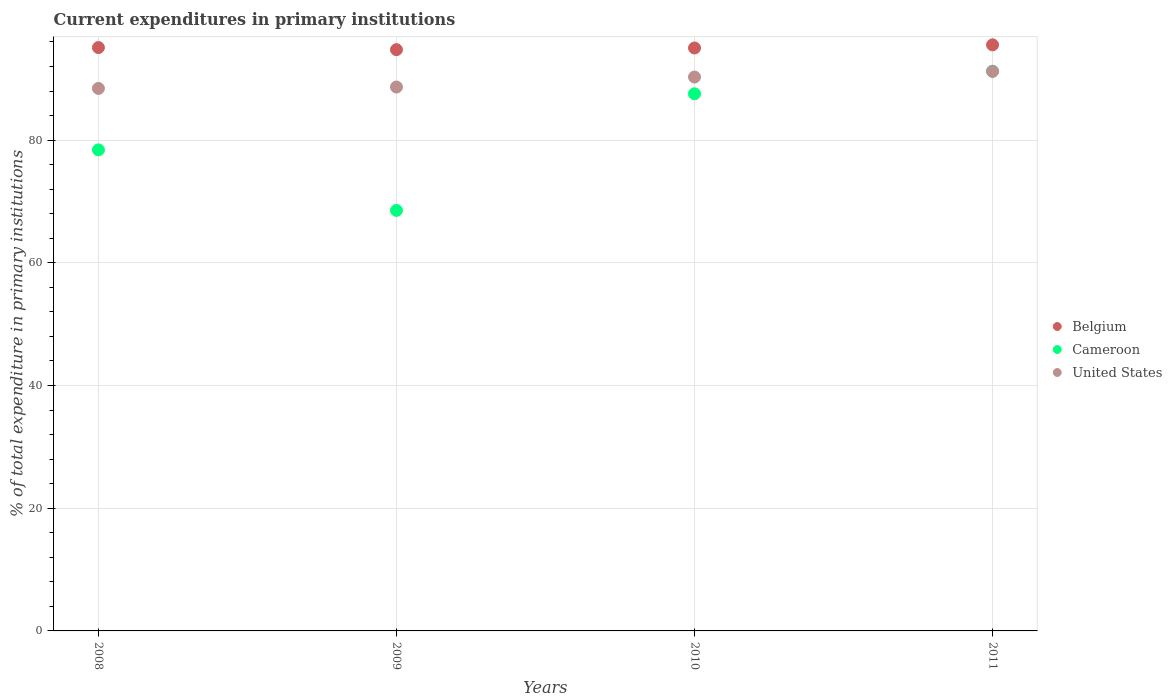Is the number of dotlines equal to the number of legend labels?
Offer a very short reply. Yes. What is the current expenditures in primary institutions in United States in 2008?
Your answer should be very brief. 88.42. Across all years, what is the maximum current expenditures in primary institutions in Cameroon?
Make the answer very short. 91.22. Across all years, what is the minimum current expenditures in primary institutions in United States?
Provide a short and direct response. 88.42. In which year was the current expenditures in primary institutions in United States maximum?
Keep it short and to the point. 2011. In which year was the current expenditures in primary institutions in Belgium minimum?
Ensure brevity in your answer.  2009. What is the total current expenditures in primary institutions in Cameroon in the graph?
Offer a very short reply. 325.71. What is the difference between the current expenditures in primary institutions in Belgium in 2009 and that in 2010?
Offer a terse response. -0.27. What is the difference between the current expenditures in primary institutions in Cameroon in 2011 and the current expenditures in primary institutions in Belgium in 2009?
Offer a terse response. -3.52. What is the average current expenditures in primary institutions in United States per year?
Offer a terse response. 89.64. In the year 2010, what is the difference between the current expenditures in primary institutions in Belgium and current expenditures in primary institutions in Cameroon?
Provide a succinct answer. 7.47. In how many years, is the current expenditures in primary institutions in Cameroon greater than 28 %?
Offer a terse response. 4. What is the ratio of the current expenditures in primary institutions in Cameroon in 2009 to that in 2011?
Your answer should be very brief. 0.75. What is the difference between the highest and the second highest current expenditures in primary institutions in United States?
Give a very brief answer. 0.93. What is the difference between the highest and the lowest current expenditures in primary institutions in Cameroon?
Offer a terse response. 22.68. Is it the case that in every year, the sum of the current expenditures in primary institutions in United States and current expenditures in primary institutions in Belgium  is greater than the current expenditures in primary institutions in Cameroon?
Offer a very short reply. Yes. Does the current expenditures in primary institutions in United States monotonically increase over the years?
Make the answer very short. Yes. Does the graph contain any zero values?
Give a very brief answer. No. Does the graph contain grids?
Your response must be concise. Yes. How many legend labels are there?
Make the answer very short. 3. How are the legend labels stacked?
Ensure brevity in your answer.  Vertical. What is the title of the graph?
Keep it short and to the point. Current expenditures in primary institutions. What is the label or title of the X-axis?
Your answer should be very brief. Years. What is the label or title of the Y-axis?
Offer a very short reply. % of total expenditure in primary institutions. What is the % of total expenditure in primary institutions of Belgium in 2008?
Your response must be concise. 95.08. What is the % of total expenditure in primary institutions of Cameroon in 2008?
Keep it short and to the point. 78.41. What is the % of total expenditure in primary institutions of United States in 2008?
Your answer should be compact. 88.42. What is the % of total expenditure in primary institutions in Belgium in 2009?
Your response must be concise. 94.74. What is the % of total expenditure in primary institutions in Cameroon in 2009?
Your response must be concise. 68.54. What is the % of total expenditure in primary institutions in United States in 2009?
Offer a very short reply. 88.65. What is the % of total expenditure in primary institutions of Belgium in 2010?
Provide a succinct answer. 95.01. What is the % of total expenditure in primary institutions in Cameroon in 2010?
Offer a terse response. 87.54. What is the % of total expenditure in primary institutions in United States in 2010?
Offer a very short reply. 90.27. What is the % of total expenditure in primary institutions of Belgium in 2011?
Your response must be concise. 95.52. What is the % of total expenditure in primary institutions of Cameroon in 2011?
Provide a short and direct response. 91.22. What is the % of total expenditure in primary institutions of United States in 2011?
Keep it short and to the point. 91.21. Across all years, what is the maximum % of total expenditure in primary institutions in Belgium?
Offer a very short reply. 95.52. Across all years, what is the maximum % of total expenditure in primary institutions in Cameroon?
Your answer should be compact. 91.22. Across all years, what is the maximum % of total expenditure in primary institutions of United States?
Your response must be concise. 91.21. Across all years, what is the minimum % of total expenditure in primary institutions in Belgium?
Offer a terse response. 94.74. Across all years, what is the minimum % of total expenditure in primary institutions of Cameroon?
Offer a very short reply. 68.54. Across all years, what is the minimum % of total expenditure in primary institutions of United States?
Your answer should be very brief. 88.42. What is the total % of total expenditure in primary institutions in Belgium in the graph?
Offer a terse response. 380.36. What is the total % of total expenditure in primary institutions of Cameroon in the graph?
Keep it short and to the point. 325.71. What is the total % of total expenditure in primary institutions of United States in the graph?
Provide a short and direct response. 358.55. What is the difference between the % of total expenditure in primary institutions in Belgium in 2008 and that in 2009?
Give a very brief answer. 0.34. What is the difference between the % of total expenditure in primary institutions of Cameroon in 2008 and that in 2009?
Keep it short and to the point. 9.87. What is the difference between the % of total expenditure in primary institutions in United States in 2008 and that in 2009?
Make the answer very short. -0.23. What is the difference between the % of total expenditure in primary institutions in Belgium in 2008 and that in 2010?
Keep it short and to the point. 0.07. What is the difference between the % of total expenditure in primary institutions in Cameroon in 2008 and that in 2010?
Your response must be concise. -9.14. What is the difference between the % of total expenditure in primary institutions in United States in 2008 and that in 2010?
Your response must be concise. -1.85. What is the difference between the % of total expenditure in primary institutions of Belgium in 2008 and that in 2011?
Your answer should be compact. -0.44. What is the difference between the % of total expenditure in primary institutions in Cameroon in 2008 and that in 2011?
Your response must be concise. -12.81. What is the difference between the % of total expenditure in primary institutions in United States in 2008 and that in 2011?
Give a very brief answer. -2.78. What is the difference between the % of total expenditure in primary institutions of Belgium in 2009 and that in 2010?
Offer a terse response. -0.27. What is the difference between the % of total expenditure in primary institutions in Cameroon in 2009 and that in 2010?
Your response must be concise. -19. What is the difference between the % of total expenditure in primary institutions in United States in 2009 and that in 2010?
Make the answer very short. -1.63. What is the difference between the % of total expenditure in primary institutions of Belgium in 2009 and that in 2011?
Keep it short and to the point. -0.78. What is the difference between the % of total expenditure in primary institutions in Cameroon in 2009 and that in 2011?
Your response must be concise. -22.68. What is the difference between the % of total expenditure in primary institutions of United States in 2009 and that in 2011?
Provide a succinct answer. -2.56. What is the difference between the % of total expenditure in primary institutions in Belgium in 2010 and that in 2011?
Ensure brevity in your answer.  -0.51. What is the difference between the % of total expenditure in primary institutions in Cameroon in 2010 and that in 2011?
Your answer should be compact. -3.68. What is the difference between the % of total expenditure in primary institutions of United States in 2010 and that in 2011?
Your answer should be compact. -0.93. What is the difference between the % of total expenditure in primary institutions of Belgium in 2008 and the % of total expenditure in primary institutions of Cameroon in 2009?
Your answer should be very brief. 26.54. What is the difference between the % of total expenditure in primary institutions of Belgium in 2008 and the % of total expenditure in primary institutions of United States in 2009?
Give a very brief answer. 6.43. What is the difference between the % of total expenditure in primary institutions of Cameroon in 2008 and the % of total expenditure in primary institutions of United States in 2009?
Offer a very short reply. -10.24. What is the difference between the % of total expenditure in primary institutions in Belgium in 2008 and the % of total expenditure in primary institutions in Cameroon in 2010?
Offer a very short reply. 7.54. What is the difference between the % of total expenditure in primary institutions of Belgium in 2008 and the % of total expenditure in primary institutions of United States in 2010?
Offer a terse response. 4.81. What is the difference between the % of total expenditure in primary institutions in Cameroon in 2008 and the % of total expenditure in primary institutions in United States in 2010?
Offer a terse response. -11.87. What is the difference between the % of total expenditure in primary institutions of Belgium in 2008 and the % of total expenditure in primary institutions of Cameroon in 2011?
Provide a short and direct response. 3.86. What is the difference between the % of total expenditure in primary institutions of Belgium in 2008 and the % of total expenditure in primary institutions of United States in 2011?
Keep it short and to the point. 3.88. What is the difference between the % of total expenditure in primary institutions in Cameroon in 2008 and the % of total expenditure in primary institutions in United States in 2011?
Ensure brevity in your answer.  -12.8. What is the difference between the % of total expenditure in primary institutions of Belgium in 2009 and the % of total expenditure in primary institutions of Cameroon in 2010?
Keep it short and to the point. 7.2. What is the difference between the % of total expenditure in primary institutions in Belgium in 2009 and the % of total expenditure in primary institutions in United States in 2010?
Keep it short and to the point. 4.46. What is the difference between the % of total expenditure in primary institutions in Cameroon in 2009 and the % of total expenditure in primary institutions in United States in 2010?
Provide a short and direct response. -21.73. What is the difference between the % of total expenditure in primary institutions of Belgium in 2009 and the % of total expenditure in primary institutions of Cameroon in 2011?
Offer a very short reply. 3.52. What is the difference between the % of total expenditure in primary institutions of Belgium in 2009 and the % of total expenditure in primary institutions of United States in 2011?
Offer a very short reply. 3.53. What is the difference between the % of total expenditure in primary institutions of Cameroon in 2009 and the % of total expenditure in primary institutions of United States in 2011?
Provide a succinct answer. -22.66. What is the difference between the % of total expenditure in primary institutions in Belgium in 2010 and the % of total expenditure in primary institutions in Cameroon in 2011?
Offer a very short reply. 3.79. What is the difference between the % of total expenditure in primary institutions in Belgium in 2010 and the % of total expenditure in primary institutions in United States in 2011?
Ensure brevity in your answer.  3.81. What is the difference between the % of total expenditure in primary institutions of Cameroon in 2010 and the % of total expenditure in primary institutions of United States in 2011?
Ensure brevity in your answer.  -3.66. What is the average % of total expenditure in primary institutions of Belgium per year?
Provide a succinct answer. 95.09. What is the average % of total expenditure in primary institutions in Cameroon per year?
Ensure brevity in your answer.  81.43. What is the average % of total expenditure in primary institutions of United States per year?
Offer a terse response. 89.64. In the year 2008, what is the difference between the % of total expenditure in primary institutions of Belgium and % of total expenditure in primary institutions of Cameroon?
Keep it short and to the point. 16.68. In the year 2008, what is the difference between the % of total expenditure in primary institutions in Belgium and % of total expenditure in primary institutions in United States?
Make the answer very short. 6.66. In the year 2008, what is the difference between the % of total expenditure in primary institutions in Cameroon and % of total expenditure in primary institutions in United States?
Make the answer very short. -10.02. In the year 2009, what is the difference between the % of total expenditure in primary institutions of Belgium and % of total expenditure in primary institutions of Cameroon?
Provide a short and direct response. 26.2. In the year 2009, what is the difference between the % of total expenditure in primary institutions in Belgium and % of total expenditure in primary institutions in United States?
Offer a very short reply. 6.09. In the year 2009, what is the difference between the % of total expenditure in primary institutions in Cameroon and % of total expenditure in primary institutions in United States?
Make the answer very short. -20.11. In the year 2010, what is the difference between the % of total expenditure in primary institutions of Belgium and % of total expenditure in primary institutions of Cameroon?
Provide a short and direct response. 7.47. In the year 2010, what is the difference between the % of total expenditure in primary institutions in Belgium and % of total expenditure in primary institutions in United States?
Keep it short and to the point. 4.74. In the year 2010, what is the difference between the % of total expenditure in primary institutions of Cameroon and % of total expenditure in primary institutions of United States?
Give a very brief answer. -2.73. In the year 2011, what is the difference between the % of total expenditure in primary institutions of Belgium and % of total expenditure in primary institutions of Cameroon?
Provide a succinct answer. 4.3. In the year 2011, what is the difference between the % of total expenditure in primary institutions of Belgium and % of total expenditure in primary institutions of United States?
Offer a terse response. 4.32. In the year 2011, what is the difference between the % of total expenditure in primary institutions in Cameroon and % of total expenditure in primary institutions in United States?
Give a very brief answer. 0.01. What is the ratio of the % of total expenditure in primary institutions in Belgium in 2008 to that in 2009?
Keep it short and to the point. 1. What is the ratio of the % of total expenditure in primary institutions in Cameroon in 2008 to that in 2009?
Ensure brevity in your answer.  1.14. What is the ratio of the % of total expenditure in primary institutions of Belgium in 2008 to that in 2010?
Provide a succinct answer. 1. What is the ratio of the % of total expenditure in primary institutions in Cameroon in 2008 to that in 2010?
Your response must be concise. 0.9. What is the ratio of the % of total expenditure in primary institutions in United States in 2008 to that in 2010?
Offer a very short reply. 0.98. What is the ratio of the % of total expenditure in primary institutions of Belgium in 2008 to that in 2011?
Provide a short and direct response. 1. What is the ratio of the % of total expenditure in primary institutions in Cameroon in 2008 to that in 2011?
Keep it short and to the point. 0.86. What is the ratio of the % of total expenditure in primary institutions of United States in 2008 to that in 2011?
Provide a short and direct response. 0.97. What is the ratio of the % of total expenditure in primary institutions in Cameroon in 2009 to that in 2010?
Offer a terse response. 0.78. What is the ratio of the % of total expenditure in primary institutions in Belgium in 2009 to that in 2011?
Offer a very short reply. 0.99. What is the ratio of the % of total expenditure in primary institutions of Cameroon in 2009 to that in 2011?
Keep it short and to the point. 0.75. What is the ratio of the % of total expenditure in primary institutions in United States in 2009 to that in 2011?
Offer a very short reply. 0.97. What is the ratio of the % of total expenditure in primary institutions of Belgium in 2010 to that in 2011?
Your response must be concise. 0.99. What is the ratio of the % of total expenditure in primary institutions in Cameroon in 2010 to that in 2011?
Your response must be concise. 0.96. What is the ratio of the % of total expenditure in primary institutions of United States in 2010 to that in 2011?
Your answer should be compact. 0.99. What is the difference between the highest and the second highest % of total expenditure in primary institutions in Belgium?
Your response must be concise. 0.44. What is the difference between the highest and the second highest % of total expenditure in primary institutions in Cameroon?
Keep it short and to the point. 3.68. What is the difference between the highest and the second highest % of total expenditure in primary institutions of United States?
Provide a short and direct response. 0.93. What is the difference between the highest and the lowest % of total expenditure in primary institutions in Belgium?
Offer a very short reply. 0.78. What is the difference between the highest and the lowest % of total expenditure in primary institutions in Cameroon?
Offer a terse response. 22.68. What is the difference between the highest and the lowest % of total expenditure in primary institutions of United States?
Your answer should be compact. 2.78. 